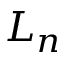<formula> <loc_0><loc_0><loc_500><loc_500>L _ { n }</formula> 